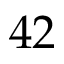<formula> <loc_0><loc_0><loc_500><loc_500>4 2</formula> 